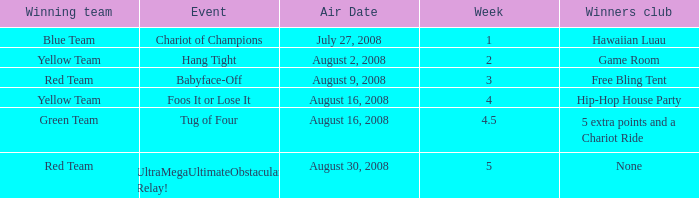Which Week has an Air Date of august 2, 2008? 2.0. 